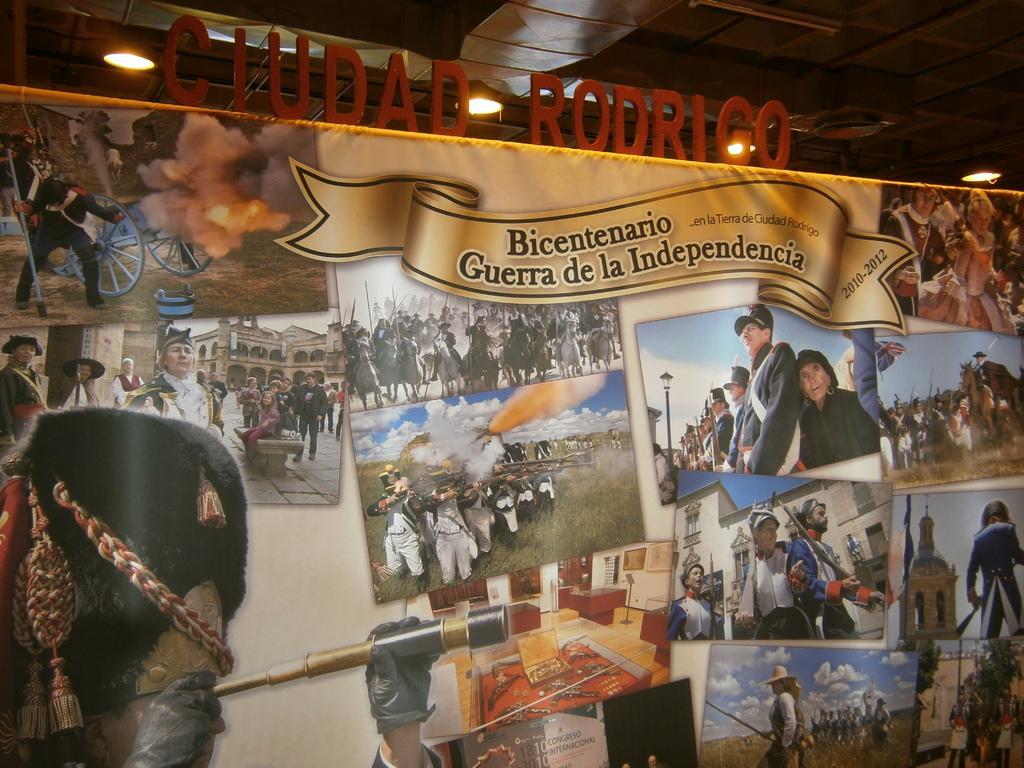Could you give a brief overview of what you see in this image? In this image I can see the banner in which I can see few pictures and I can see few people, buildings, grass, sky and few objects. I can see few lights and the boards. 